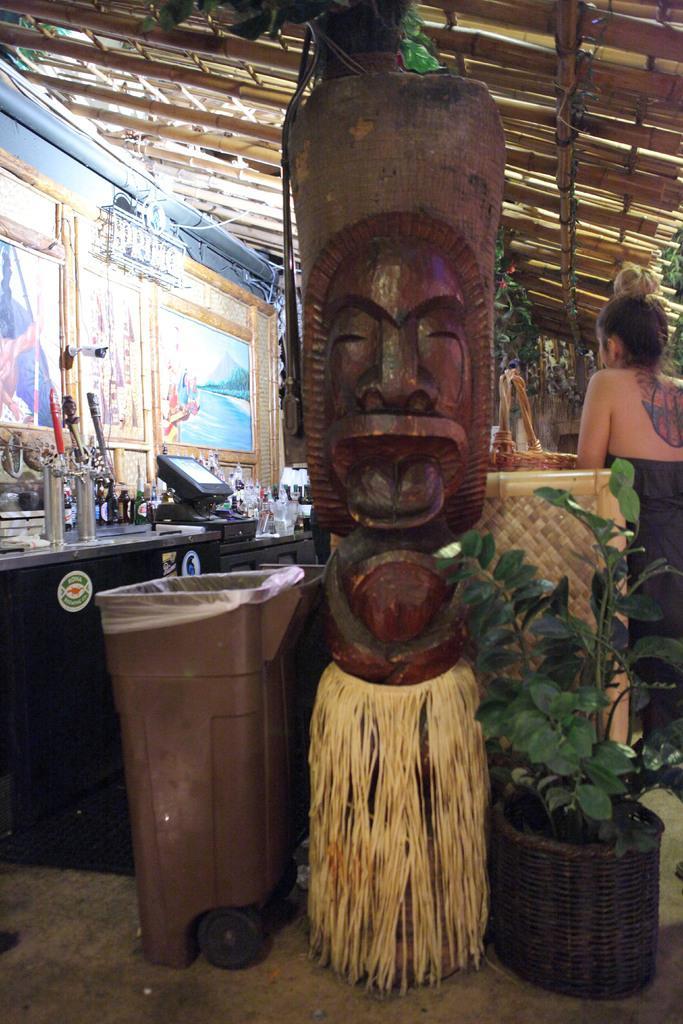Can you describe this image briefly? In this image in the foreground I can see there is a wooden structure and dustbin on the left side and a plant on the right side. 